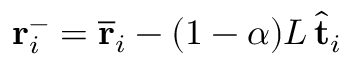<formula> <loc_0><loc_0><loc_500><loc_500>r _ { i } ^ { - } = \overline { r } _ { i } - ( 1 - \alpha ) L \, \hat { t } _ { i }</formula> 